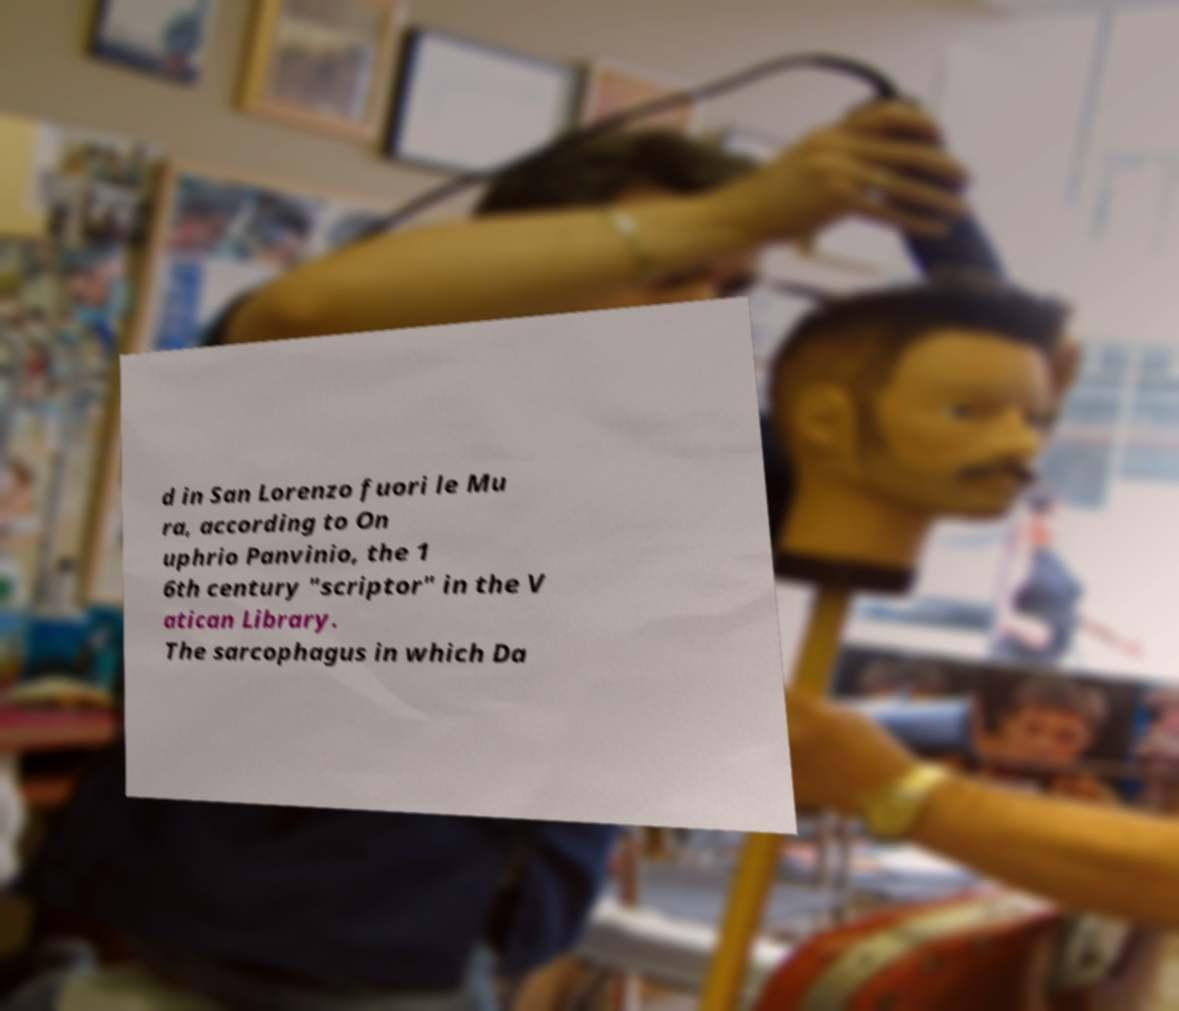Please read and relay the text visible in this image. What does it say? d in San Lorenzo fuori le Mu ra, according to On uphrio Panvinio, the 1 6th century "scriptor" in the V atican Library. The sarcophagus in which Da 